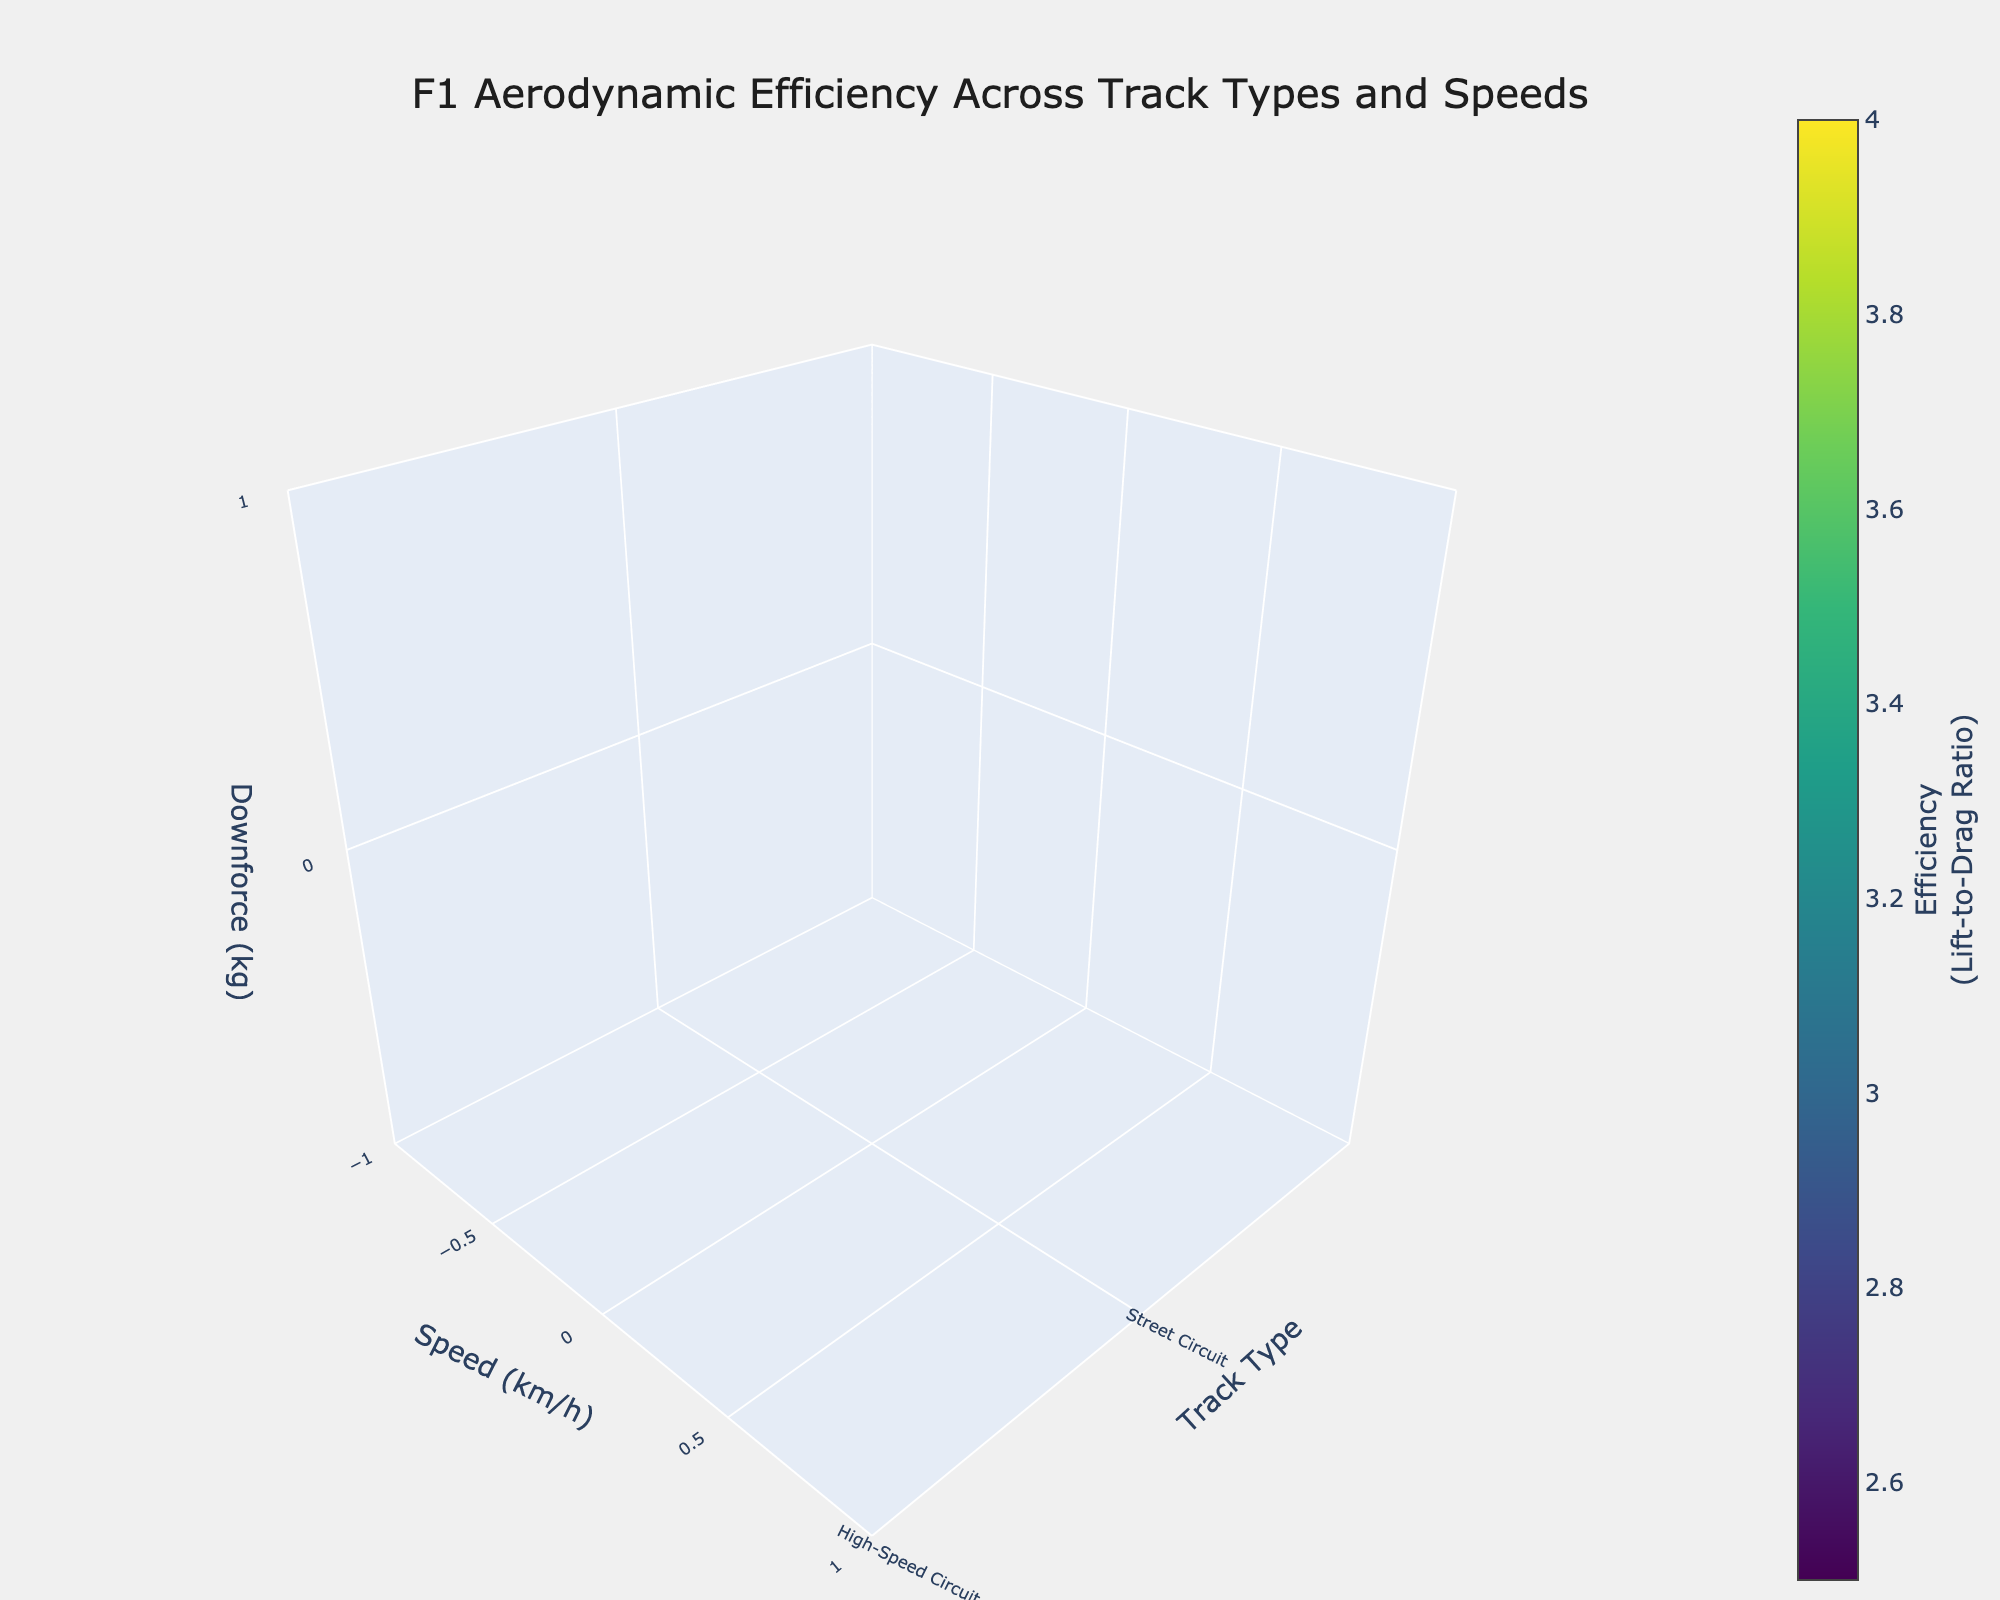how many Track Types are shown in the figure? The figure has data points plotted for each unique track type. You can count the distinct types listed in the axis labeled 'Track Type'.
Answer: 5 What is the color scale used in the figure? The 3D volume plot uses a color scale as a visual aid to represent efficiency values. According to the information provided, the color scale used is called "Viridis".
Answer: Viridis Which track type shows the highest downforce at 300 km/h? To find out which track type shows the highest downforce at 300 km/h, look at the data points corresponding to a speed of 300 km/h and compare the downforce values. From the data, the track type "Monaco" has the highest downforce at 300 km/h.
Answer: Monaco What's the average efficiency at 200 km/h across all track types? To find the average efficiency at 200 km/h, sum up the efficiencies for all track types at this speed and divide by the number of track types. The efficiencies are 3.2 (Street Circuit), 3.5 (High-Speed Circuit), 3.0 (Technical Circuit), 3.7 (Monza), and 2.9 (Monaco). So, average = (3.2 + 3.5 + 3.0 + 3.7 + 2.9) / 5 = 3.26.
Answer: 3.26 Which track type has the most consistent efficiency values across different speeds? To identify the track type with the most consistent efficiency values across different speeds, examine the figures and see which track type has the least variation in efficiency. Based on the data, "Street Circuit" and "Technical Circuit" show less fluctuation across speeds compared to the others.
Answer: Street Circuit Is there any track type that maintains a downforce under 1000 kg for all speeds mentioned? Look at the data for each track type and check if any maintain a downforce value below 1000 kg for all listed speeds (100, 200, 300 km/h). Only Monza and High-Speed Circuit have downforce values consistently under 1000 kg at all speeds.
Answer: No How does the efficiency at 100 km/h on Technical Circuit compare to 200 km/h on the same track? To compare efficiency at different speeds on the Technical Circuit, look at the efficiency values for 100 km/h and 200 km/h. The values are 2.6 at 100 km/h and 3.0 at 200 km/h. So, the efficiency at 100 km/h is lower than at 200 km/h.
Answer: Lower What is the relationship between downforce and efficiency? Observe the different data points and see how variation in downforce affects efficiency. Generally, an increase in downforce results in higher efficiency based on the data provided for each track type and speed combination.
Answer: Positive correlation 